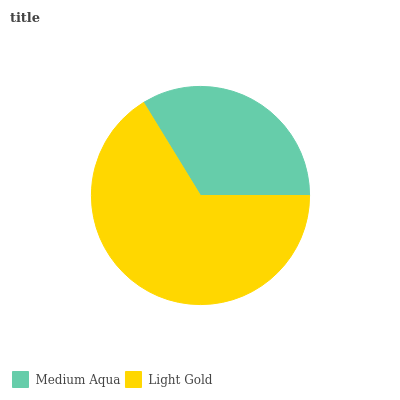Is Medium Aqua the minimum?
Answer yes or no. Yes. Is Light Gold the maximum?
Answer yes or no. Yes. Is Light Gold the minimum?
Answer yes or no. No. Is Light Gold greater than Medium Aqua?
Answer yes or no. Yes. Is Medium Aqua less than Light Gold?
Answer yes or no. Yes. Is Medium Aqua greater than Light Gold?
Answer yes or no. No. Is Light Gold less than Medium Aqua?
Answer yes or no. No. Is Light Gold the high median?
Answer yes or no. Yes. Is Medium Aqua the low median?
Answer yes or no. Yes. Is Medium Aqua the high median?
Answer yes or no. No. Is Light Gold the low median?
Answer yes or no. No. 